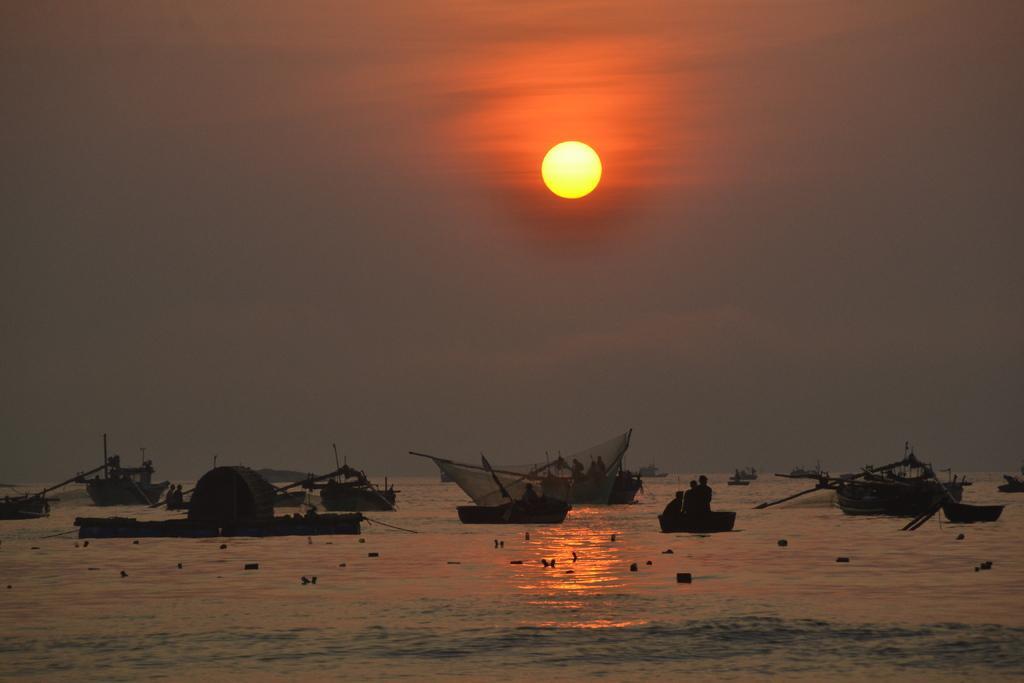Can you describe this image briefly? In this image there are group of people in the boats , which are on the water , and in the background there is sun in the sky. 